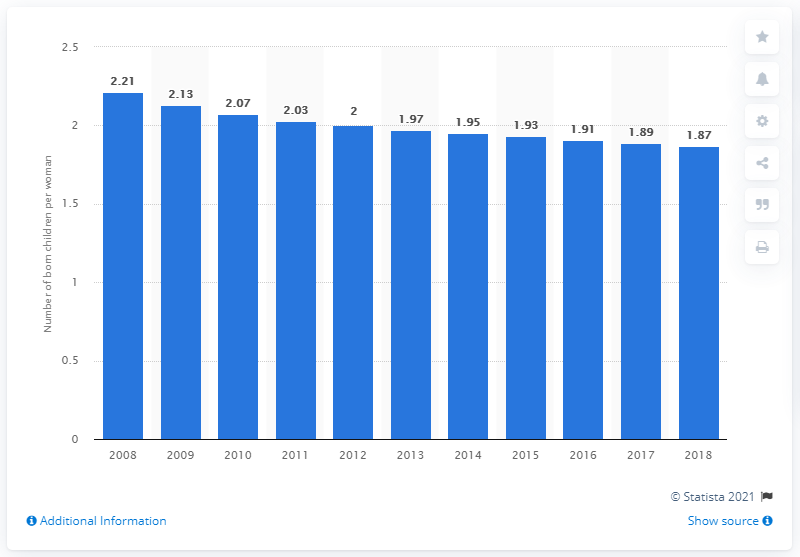Give some essential details in this illustration. The fertility rate in Qatar was 1.87 in 2018. 